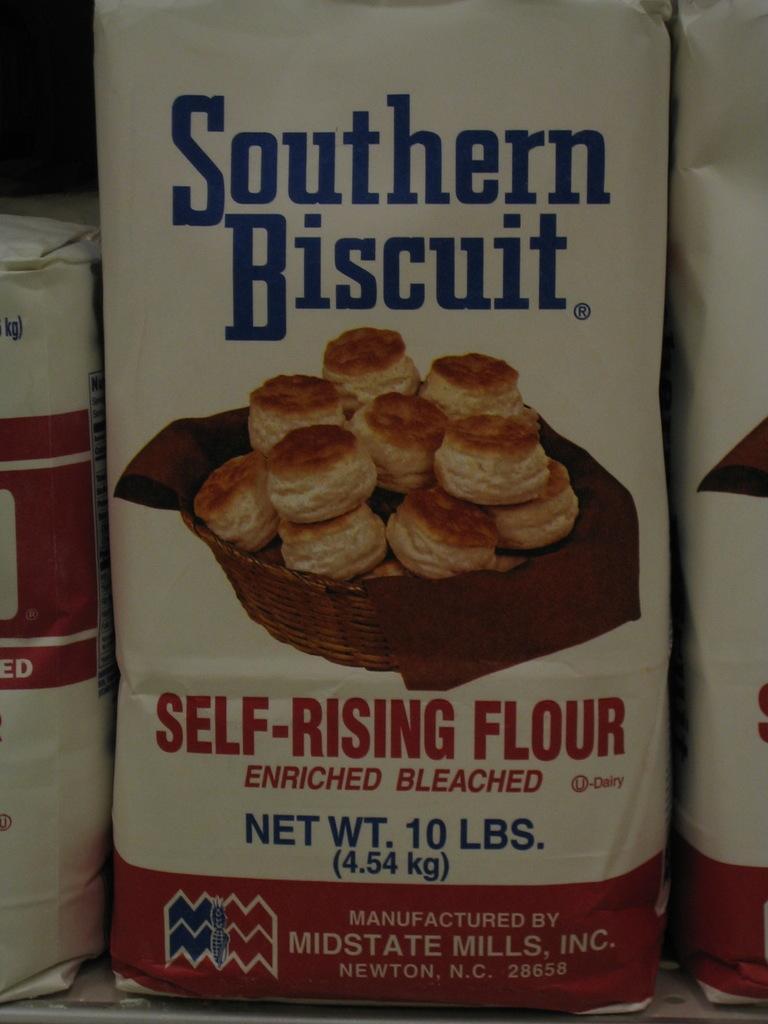In one or two sentences, can you explain what this image depicts? In this image, in the middle there is a packet, poster, on that there are food items, text, logo, basket. On the left and right there are packets. 